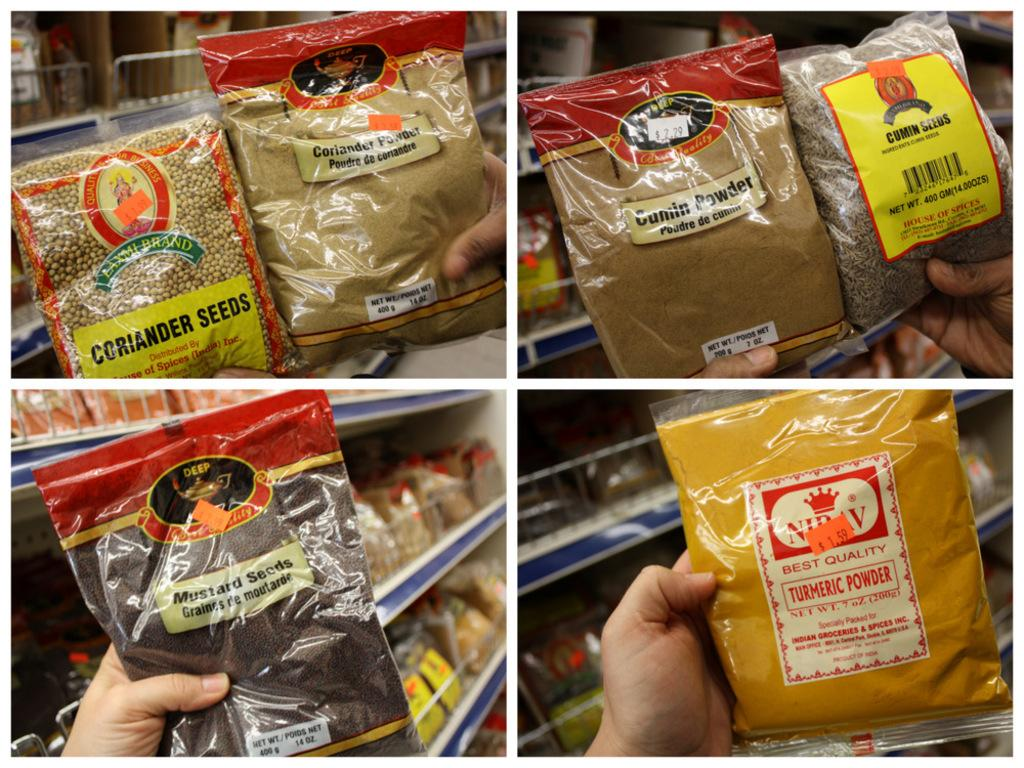What is the main subject of the image? There is a person in the image. What is the person doing in the image? The person is holding some items. Can you describe what part of the person is visible in the image? Only the person's hands are visible in the image. What type of watch is the person's aunt wearing in the image? There is no watch or aunt present in the image; only the person's hands are visible. 